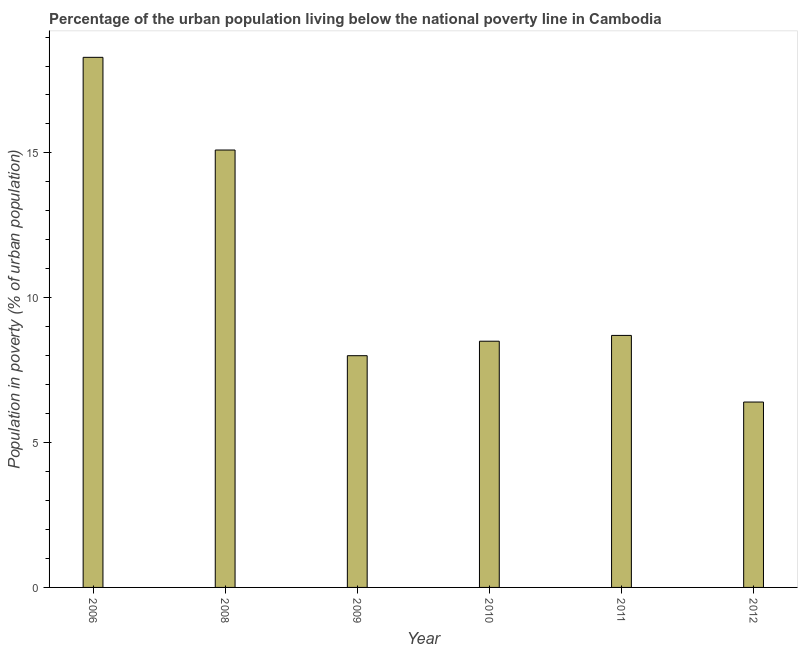Does the graph contain any zero values?
Provide a short and direct response. No. Does the graph contain grids?
Offer a very short reply. No. What is the title of the graph?
Provide a short and direct response. Percentage of the urban population living below the national poverty line in Cambodia. What is the label or title of the X-axis?
Your answer should be compact. Year. What is the label or title of the Y-axis?
Your answer should be very brief. Population in poverty (% of urban population). Across all years, what is the minimum percentage of urban population living below poverty line?
Keep it short and to the point. 6.4. In which year was the percentage of urban population living below poverty line minimum?
Your response must be concise. 2012. What is the sum of the percentage of urban population living below poverty line?
Give a very brief answer. 65. What is the average percentage of urban population living below poverty line per year?
Your answer should be compact. 10.83. What is the median percentage of urban population living below poverty line?
Keep it short and to the point. 8.6. In how many years, is the percentage of urban population living below poverty line greater than 13 %?
Give a very brief answer. 2. Do a majority of the years between 2009 and 2011 (inclusive) have percentage of urban population living below poverty line greater than 15 %?
Offer a terse response. No. What is the ratio of the percentage of urban population living below poverty line in 2008 to that in 2011?
Keep it short and to the point. 1.74. Is the percentage of urban population living below poverty line in 2010 less than that in 2012?
Your response must be concise. No. What is the difference between the highest and the second highest percentage of urban population living below poverty line?
Your answer should be very brief. 3.2. Is the sum of the percentage of urban population living below poverty line in 2009 and 2010 greater than the maximum percentage of urban population living below poverty line across all years?
Your answer should be compact. No. What is the difference between the highest and the lowest percentage of urban population living below poverty line?
Provide a succinct answer. 11.9. What is the difference between two consecutive major ticks on the Y-axis?
Keep it short and to the point. 5. Are the values on the major ticks of Y-axis written in scientific E-notation?
Offer a very short reply. No. What is the Population in poverty (% of urban population) in 2008?
Your response must be concise. 15.1. What is the Population in poverty (% of urban population) of 2011?
Provide a succinct answer. 8.7. What is the Population in poverty (% of urban population) of 2012?
Keep it short and to the point. 6.4. What is the difference between the Population in poverty (% of urban population) in 2006 and 2008?
Your answer should be compact. 3.2. What is the difference between the Population in poverty (% of urban population) in 2006 and 2009?
Your answer should be compact. 10.3. What is the difference between the Population in poverty (% of urban population) in 2006 and 2010?
Offer a terse response. 9.8. What is the difference between the Population in poverty (% of urban population) in 2009 and 2010?
Offer a very short reply. -0.5. What is the difference between the Population in poverty (% of urban population) in 2009 and 2011?
Your answer should be compact. -0.7. What is the difference between the Population in poverty (% of urban population) in 2009 and 2012?
Keep it short and to the point. 1.6. What is the difference between the Population in poverty (% of urban population) in 2011 and 2012?
Your answer should be very brief. 2.3. What is the ratio of the Population in poverty (% of urban population) in 2006 to that in 2008?
Keep it short and to the point. 1.21. What is the ratio of the Population in poverty (% of urban population) in 2006 to that in 2009?
Provide a short and direct response. 2.29. What is the ratio of the Population in poverty (% of urban population) in 2006 to that in 2010?
Ensure brevity in your answer.  2.15. What is the ratio of the Population in poverty (% of urban population) in 2006 to that in 2011?
Make the answer very short. 2.1. What is the ratio of the Population in poverty (% of urban population) in 2006 to that in 2012?
Your response must be concise. 2.86. What is the ratio of the Population in poverty (% of urban population) in 2008 to that in 2009?
Your answer should be compact. 1.89. What is the ratio of the Population in poverty (% of urban population) in 2008 to that in 2010?
Your answer should be very brief. 1.78. What is the ratio of the Population in poverty (% of urban population) in 2008 to that in 2011?
Your response must be concise. 1.74. What is the ratio of the Population in poverty (% of urban population) in 2008 to that in 2012?
Give a very brief answer. 2.36. What is the ratio of the Population in poverty (% of urban population) in 2009 to that in 2010?
Make the answer very short. 0.94. What is the ratio of the Population in poverty (% of urban population) in 2009 to that in 2012?
Ensure brevity in your answer.  1.25. What is the ratio of the Population in poverty (% of urban population) in 2010 to that in 2012?
Provide a short and direct response. 1.33. What is the ratio of the Population in poverty (% of urban population) in 2011 to that in 2012?
Provide a succinct answer. 1.36. 